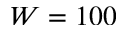<formula> <loc_0><loc_0><loc_500><loc_500>W = 1 0 0</formula> 